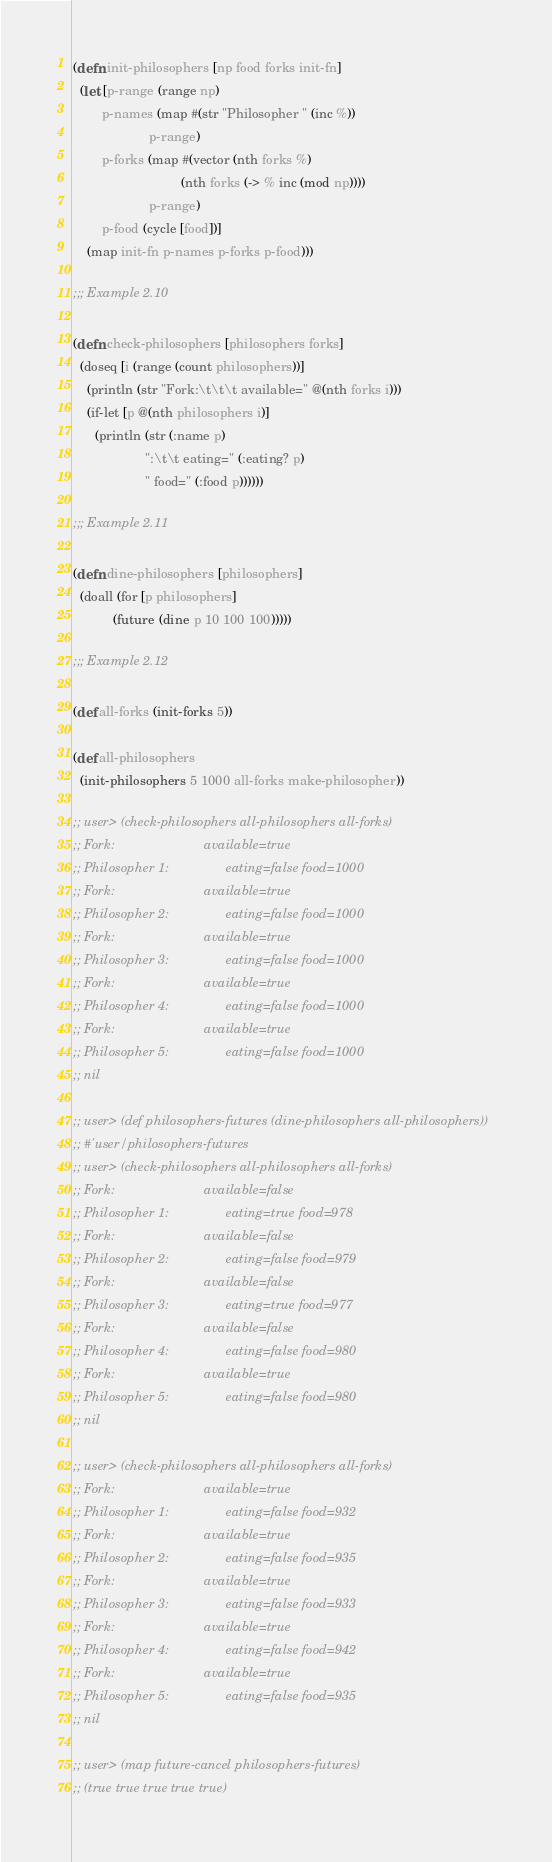<code> <loc_0><loc_0><loc_500><loc_500><_Clojure_>(defn init-philosophers [np food forks init-fn]
  (let [p-range (range np)
        p-names (map #(str "Philosopher " (inc %))
                     p-range)
        p-forks (map #(vector (nth forks %)
                              (nth forks (-> % inc (mod np))))
                     p-range)
        p-food (cycle [food])]
    (map init-fn p-names p-forks p-food)))

;;; Example 2.10

(defn check-philosophers [philosophers forks]
  (doseq [i (range (count philosophers))]
    (println (str "Fork:\t\t\t available=" @(nth forks i)))
    (if-let [p @(nth philosophers i)]
      (println (str (:name p)
                    ":\t\t eating=" (:eating? p)
                    " food=" (:food p))))))

;;; Example 2.11

(defn dine-philosophers [philosophers]
  (doall (for [p philosophers]
           (future (dine p 10 100 100)))))

;;; Example 2.12

(def all-forks (init-forks 5))

(def all-philosophers
  (init-philosophers 5 1000 all-forks make-philosopher))

;; user> (check-philosophers all-philosophers all-forks)
;; Fork:                         available=true
;; Philosopher 1:                eating=false food=1000
;; Fork:                         available=true
;; Philosopher 2:                eating=false food=1000
;; Fork:                         available=true
;; Philosopher 3:                eating=false food=1000
;; Fork:                         available=true
;; Philosopher 4:                eating=false food=1000
;; Fork:                         available=true
;; Philosopher 5:                eating=false food=1000
;; nil

;; user> (def philosophers-futures (dine-philosophers all-philosophers))
;; #'user/philosophers-futures
;; user> (check-philosophers all-philosophers all-forks)
;; Fork:                         available=false
;; Philosopher 1:                eating=true food=978
;; Fork:                         available=false
;; Philosopher 2:                eating=false food=979
;; Fork:                         available=false
;; Philosopher 3:                eating=true food=977
;; Fork:                         available=false
;; Philosopher 4:                eating=false food=980
;; Fork:                         available=true
;; Philosopher 5:                eating=false food=980
;; nil

;; user> (check-philosophers all-philosophers all-forks)
;; Fork:                         available=true
;; Philosopher 1:                eating=false food=932
;; Fork:                         available=true
;; Philosopher 2:                eating=false food=935
;; Fork:                         available=true
;; Philosopher 3:                eating=false food=933
;; Fork:                         available=true
;; Philosopher 4:                eating=false food=942
;; Fork:                         available=true
;; Philosopher 5:                eating=false food=935
;; nil

;; user> (map future-cancel philosophers-futures)
;; (true true true true true)
</code> 